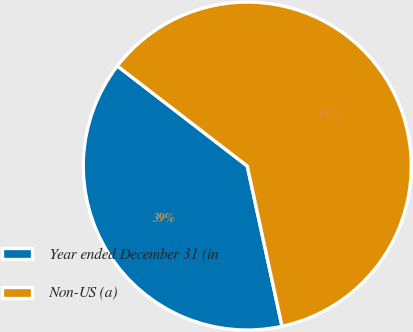<chart> <loc_0><loc_0><loc_500><loc_500><pie_chart><fcel>Year ended December 31 (in<fcel>Non-US (a)<nl><fcel>38.85%<fcel>61.15%<nl></chart> 